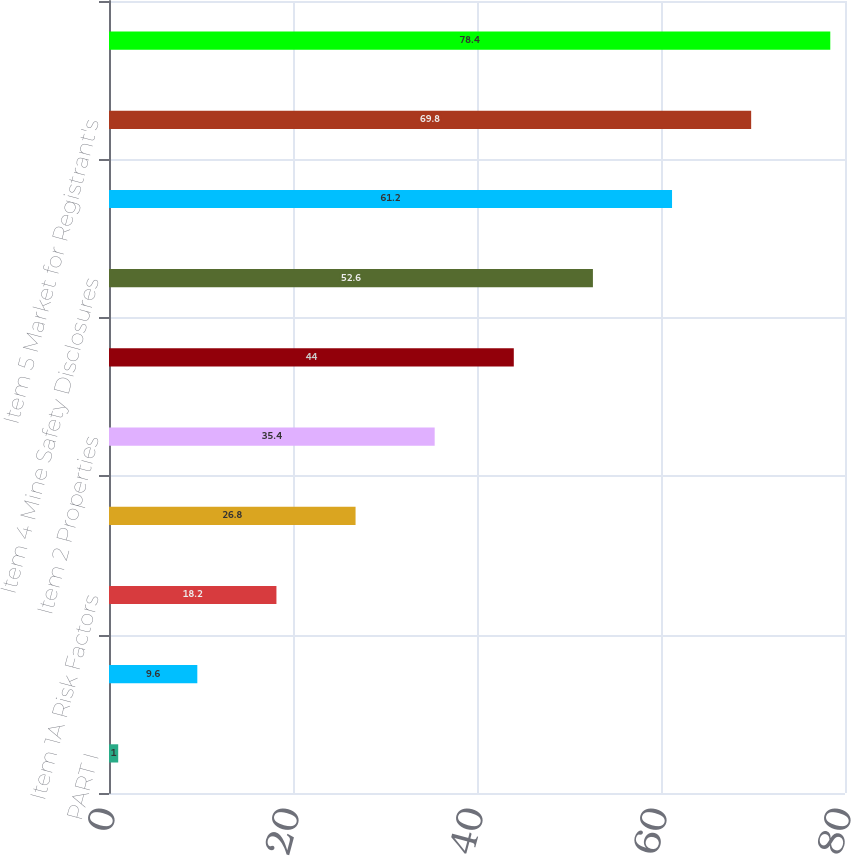Convert chart to OTSL. <chart><loc_0><loc_0><loc_500><loc_500><bar_chart><fcel>PART I<fcel>Item 1 Business<fcel>Item 1A Risk Factors<fcel>Item 1B Unresolved Staff<fcel>Item 2 Properties<fcel>Item 3 Legal Proceedings<fcel>Item 4 Mine Safety Disclosures<fcel>PART II<fcel>Item 5 Market for Registrant's<fcel>Item 6 Selected Financial Data<nl><fcel>1<fcel>9.6<fcel>18.2<fcel>26.8<fcel>35.4<fcel>44<fcel>52.6<fcel>61.2<fcel>69.8<fcel>78.4<nl></chart> 